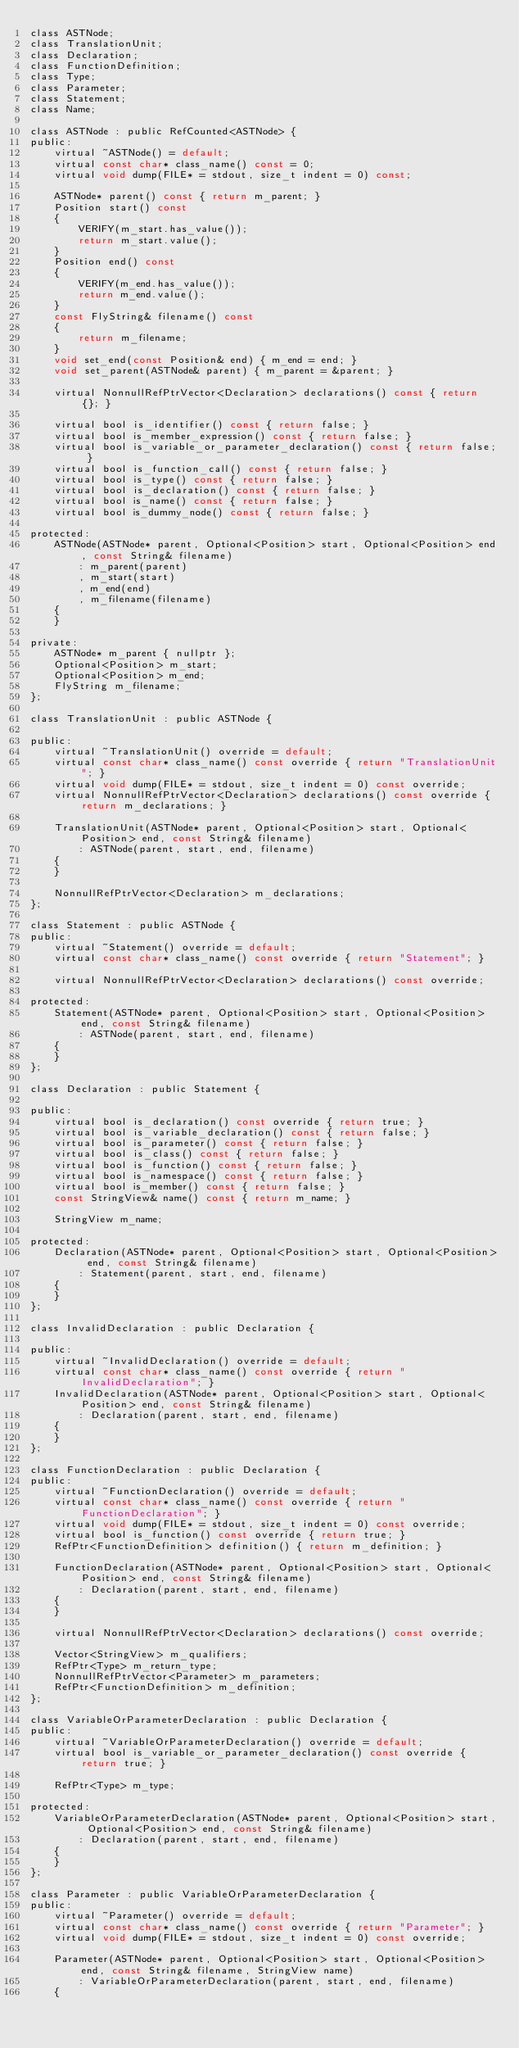<code> <loc_0><loc_0><loc_500><loc_500><_C_>class ASTNode;
class TranslationUnit;
class Declaration;
class FunctionDefinition;
class Type;
class Parameter;
class Statement;
class Name;

class ASTNode : public RefCounted<ASTNode> {
public:
    virtual ~ASTNode() = default;
    virtual const char* class_name() const = 0;
    virtual void dump(FILE* = stdout, size_t indent = 0) const;

    ASTNode* parent() const { return m_parent; }
    Position start() const
    {
        VERIFY(m_start.has_value());
        return m_start.value();
    }
    Position end() const
    {
        VERIFY(m_end.has_value());
        return m_end.value();
    }
    const FlyString& filename() const
    {
        return m_filename;
    }
    void set_end(const Position& end) { m_end = end; }
    void set_parent(ASTNode& parent) { m_parent = &parent; }

    virtual NonnullRefPtrVector<Declaration> declarations() const { return {}; }

    virtual bool is_identifier() const { return false; }
    virtual bool is_member_expression() const { return false; }
    virtual bool is_variable_or_parameter_declaration() const { return false; }
    virtual bool is_function_call() const { return false; }
    virtual bool is_type() const { return false; }
    virtual bool is_declaration() const { return false; }
    virtual bool is_name() const { return false; }
    virtual bool is_dummy_node() const { return false; }

protected:
    ASTNode(ASTNode* parent, Optional<Position> start, Optional<Position> end, const String& filename)
        : m_parent(parent)
        , m_start(start)
        , m_end(end)
        , m_filename(filename)
    {
    }

private:
    ASTNode* m_parent { nullptr };
    Optional<Position> m_start;
    Optional<Position> m_end;
    FlyString m_filename;
};

class TranslationUnit : public ASTNode {

public:
    virtual ~TranslationUnit() override = default;
    virtual const char* class_name() const override { return "TranslationUnit"; }
    virtual void dump(FILE* = stdout, size_t indent = 0) const override;
    virtual NonnullRefPtrVector<Declaration> declarations() const override { return m_declarations; }

    TranslationUnit(ASTNode* parent, Optional<Position> start, Optional<Position> end, const String& filename)
        : ASTNode(parent, start, end, filename)
    {
    }

    NonnullRefPtrVector<Declaration> m_declarations;
};

class Statement : public ASTNode {
public:
    virtual ~Statement() override = default;
    virtual const char* class_name() const override { return "Statement"; }

    virtual NonnullRefPtrVector<Declaration> declarations() const override;

protected:
    Statement(ASTNode* parent, Optional<Position> start, Optional<Position> end, const String& filename)
        : ASTNode(parent, start, end, filename)
    {
    }
};

class Declaration : public Statement {

public:
    virtual bool is_declaration() const override { return true; }
    virtual bool is_variable_declaration() const { return false; }
    virtual bool is_parameter() const { return false; }
    virtual bool is_class() const { return false; }
    virtual bool is_function() const { return false; }
    virtual bool is_namespace() const { return false; }
    virtual bool is_member() const { return false; }
    const StringView& name() const { return m_name; }

    StringView m_name;

protected:
    Declaration(ASTNode* parent, Optional<Position> start, Optional<Position> end, const String& filename)
        : Statement(parent, start, end, filename)
    {
    }
};

class InvalidDeclaration : public Declaration {

public:
    virtual ~InvalidDeclaration() override = default;
    virtual const char* class_name() const override { return "InvalidDeclaration"; }
    InvalidDeclaration(ASTNode* parent, Optional<Position> start, Optional<Position> end, const String& filename)
        : Declaration(parent, start, end, filename)
    {
    }
};

class FunctionDeclaration : public Declaration {
public:
    virtual ~FunctionDeclaration() override = default;
    virtual const char* class_name() const override { return "FunctionDeclaration"; }
    virtual void dump(FILE* = stdout, size_t indent = 0) const override;
    virtual bool is_function() const override { return true; }
    RefPtr<FunctionDefinition> definition() { return m_definition; }

    FunctionDeclaration(ASTNode* parent, Optional<Position> start, Optional<Position> end, const String& filename)
        : Declaration(parent, start, end, filename)
    {
    }

    virtual NonnullRefPtrVector<Declaration> declarations() const override;

    Vector<StringView> m_qualifiers;
    RefPtr<Type> m_return_type;
    NonnullRefPtrVector<Parameter> m_parameters;
    RefPtr<FunctionDefinition> m_definition;
};

class VariableOrParameterDeclaration : public Declaration {
public:
    virtual ~VariableOrParameterDeclaration() override = default;
    virtual bool is_variable_or_parameter_declaration() const override { return true; }

    RefPtr<Type> m_type;

protected:
    VariableOrParameterDeclaration(ASTNode* parent, Optional<Position> start, Optional<Position> end, const String& filename)
        : Declaration(parent, start, end, filename)
    {
    }
};

class Parameter : public VariableOrParameterDeclaration {
public:
    virtual ~Parameter() override = default;
    virtual const char* class_name() const override { return "Parameter"; }
    virtual void dump(FILE* = stdout, size_t indent = 0) const override;

    Parameter(ASTNode* parent, Optional<Position> start, Optional<Position> end, const String& filename, StringView name)
        : VariableOrParameterDeclaration(parent, start, end, filename)
    {</code> 